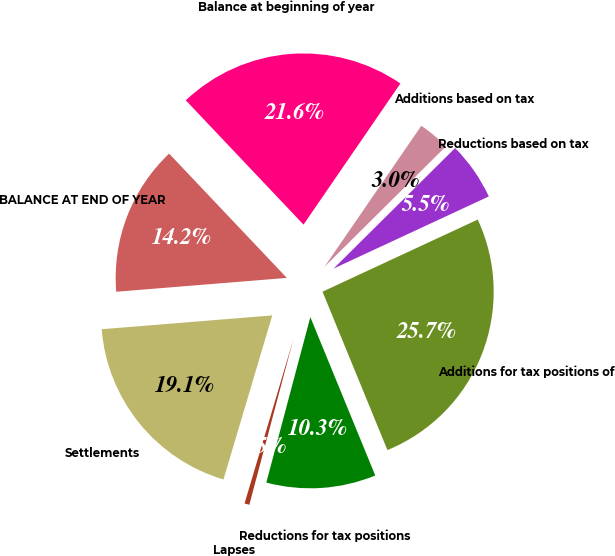Convert chart. <chart><loc_0><loc_0><loc_500><loc_500><pie_chart><fcel>Balance at beginning of year<fcel>Additions based on tax<fcel>Reductions based on tax<fcel>Additions for tax positions of<fcel>Reductions for tax positions<fcel>Lapses<fcel>Settlements<fcel>BALANCE AT END OF YEAR<nl><fcel>21.64%<fcel>2.99%<fcel>5.51%<fcel>25.73%<fcel>10.33%<fcel>0.46%<fcel>19.11%<fcel>14.22%<nl></chart> 